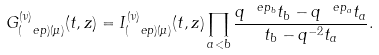<formula> <loc_0><loc_0><loc_500><loc_500>G ^ { ( \nu ) } _ { ( \ e p ) ( \mu ) } ( t , z ) = I ^ { ( \nu ) } _ { ( \ e p ) ( \mu ) } ( t , z ) \prod _ { a < b } \frac { q ^ { \ e p _ { b } } t _ { b } - q ^ { \ e p _ { a } } t _ { a } } { t _ { b } - q ^ { - 2 } t _ { a } } .</formula> 